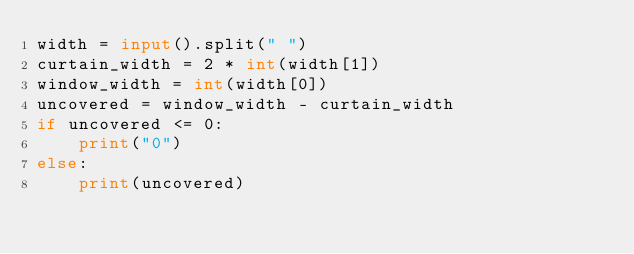Convert code to text. <code><loc_0><loc_0><loc_500><loc_500><_Python_>width = input().split(" ")
curtain_width = 2 * int(width[1])
window_width = int(width[0])
uncovered = window_width - curtain_width
if uncovered <= 0:
    print("0")
else:
    print(uncovered)</code> 